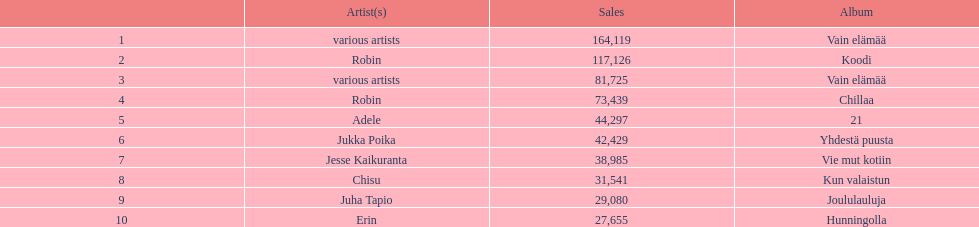Which album had the least amount of sales? Hunningolla. 